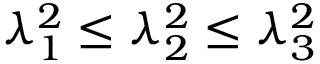<formula> <loc_0><loc_0><loc_500><loc_500>\lambda _ { 1 } ^ { 2 } \leq \lambda _ { 2 } ^ { 2 } \leq \lambda _ { 3 } ^ { 2 }</formula> 